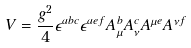Convert formula to latex. <formula><loc_0><loc_0><loc_500><loc_500>V = \frac { g ^ { 2 } } { 4 } \epsilon ^ { a b c } \epsilon ^ { a e f } A _ { \mu } ^ { b } A _ { \nu } ^ { c } A ^ { \mu e } A ^ { \nu f }</formula> 